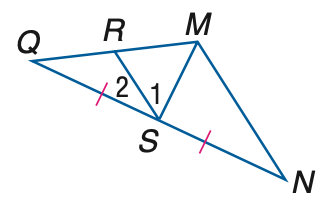Question: If M S is a median of \triangle M N Q, Q S = 3 a - 14, S N = 2 a + 1, and m \angle M S Q = 7 a + 1, find the value of a.
Choices:
A. 13
B. 14
C. 15
D. 16
Answer with the letter. Answer: C Question: Find x if M S is an altitude of \triangle M N Q, m \angle 1 = 3 x + 11, and m \angle 2 = 7 x + 9.
Choices:
A. 5
B. 7
C. 9
D. 11
Answer with the letter. Answer: B 